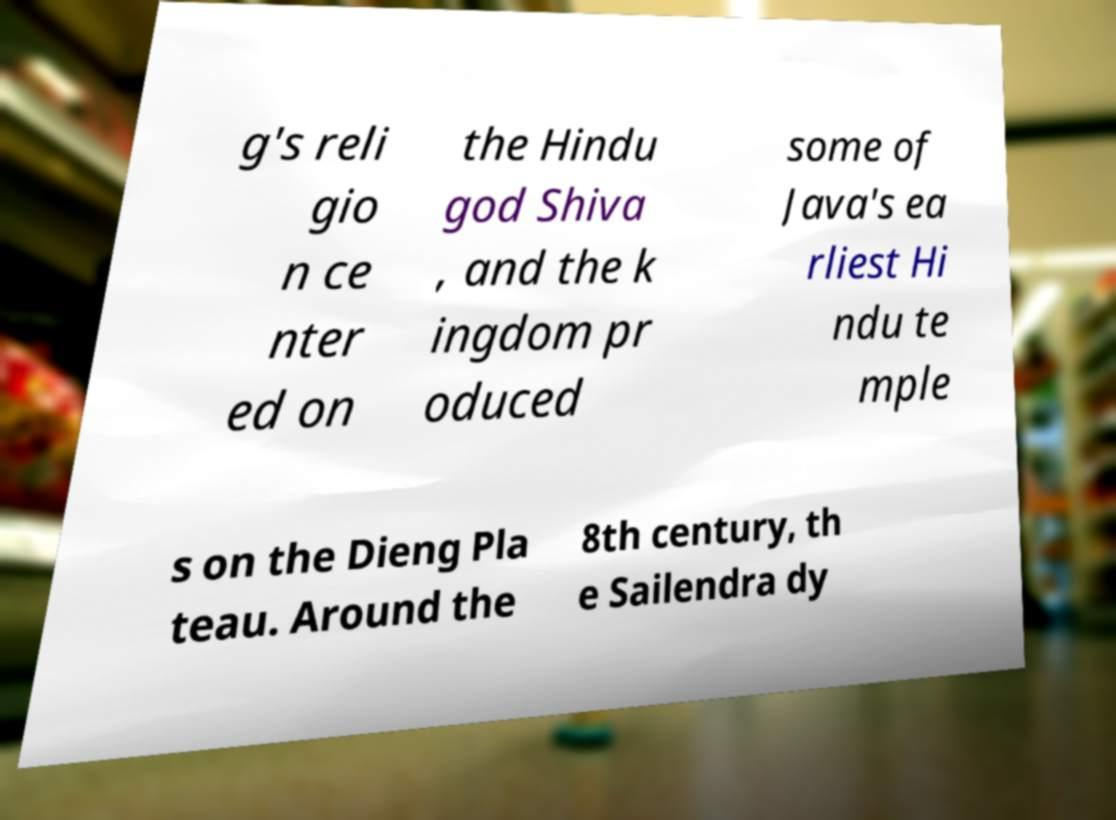I need the written content from this picture converted into text. Can you do that? g's reli gio n ce nter ed on the Hindu god Shiva , and the k ingdom pr oduced some of Java's ea rliest Hi ndu te mple s on the Dieng Pla teau. Around the 8th century, th e Sailendra dy 